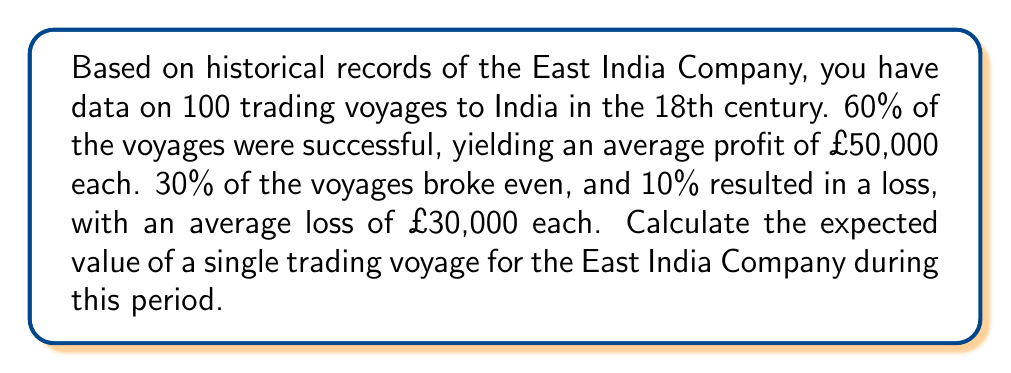What is the answer to this math problem? To calculate the expected value of a trading voyage, we need to consider all possible outcomes and their respective probabilities. Let's break this down step-by-step:

1. Identify the outcomes and their probabilities:
   - Successful voyage: 60% probability (0.60)
   - Break-even voyage: 30% probability (0.30)
   - Loss-making voyage: 10% probability (0.10)

2. Determine the value for each outcome:
   - Successful voyage: £50,000 profit
   - Break-even voyage: £0 (no profit, no loss)
   - Loss-making voyage: £30,000 loss (represented as -£30,000)

3. Calculate the expected value using the formula:

   $$E(X) = \sum_{i=1}^{n} p_i \cdot x_i$$

   Where:
   $E(X)$ is the expected value
   $p_i$ is the probability of each outcome
   $x_i$ is the value of each outcome

4. Plug in the values:

   $$E(X) = (0.60 \cdot 50000) + (0.30 \cdot 0) + (0.10 \cdot (-30000))$$

5. Solve the equation:

   $$E(X) = 30000 + 0 - 3000$$
   $$E(X) = 27000$$

Therefore, the expected value of a single trading voyage for the East India Company during this period is £27,000.
Answer: £27,000 